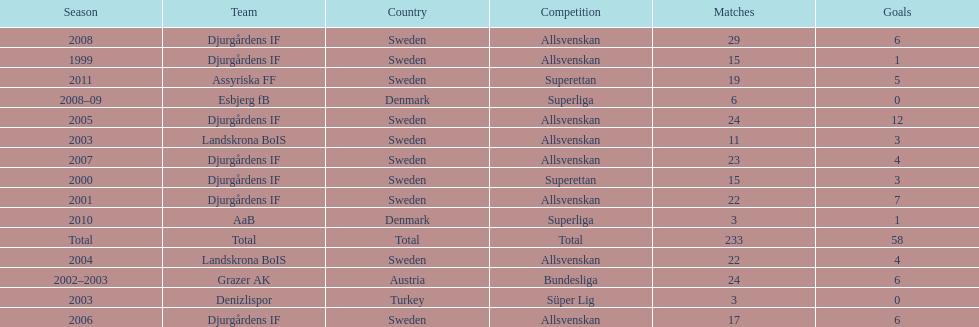What country is team djurgårdens if not from? Sweden. 